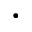<formula> <loc_0><loc_0><loc_500><loc_500>\cdot</formula> 